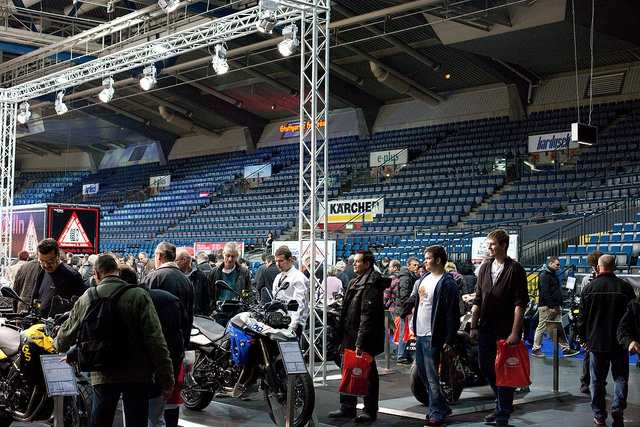Describe the objects in this image and their specific colors. I can see people in gray, black, lightgray, and darkgray tones, people in gray, black, and darkgray tones, motorcycle in gray, black, darkgray, and lightgray tones, motorcycle in gray, black, darkgray, and lightgray tones, and people in gray, black, navy, and darkblue tones in this image. 